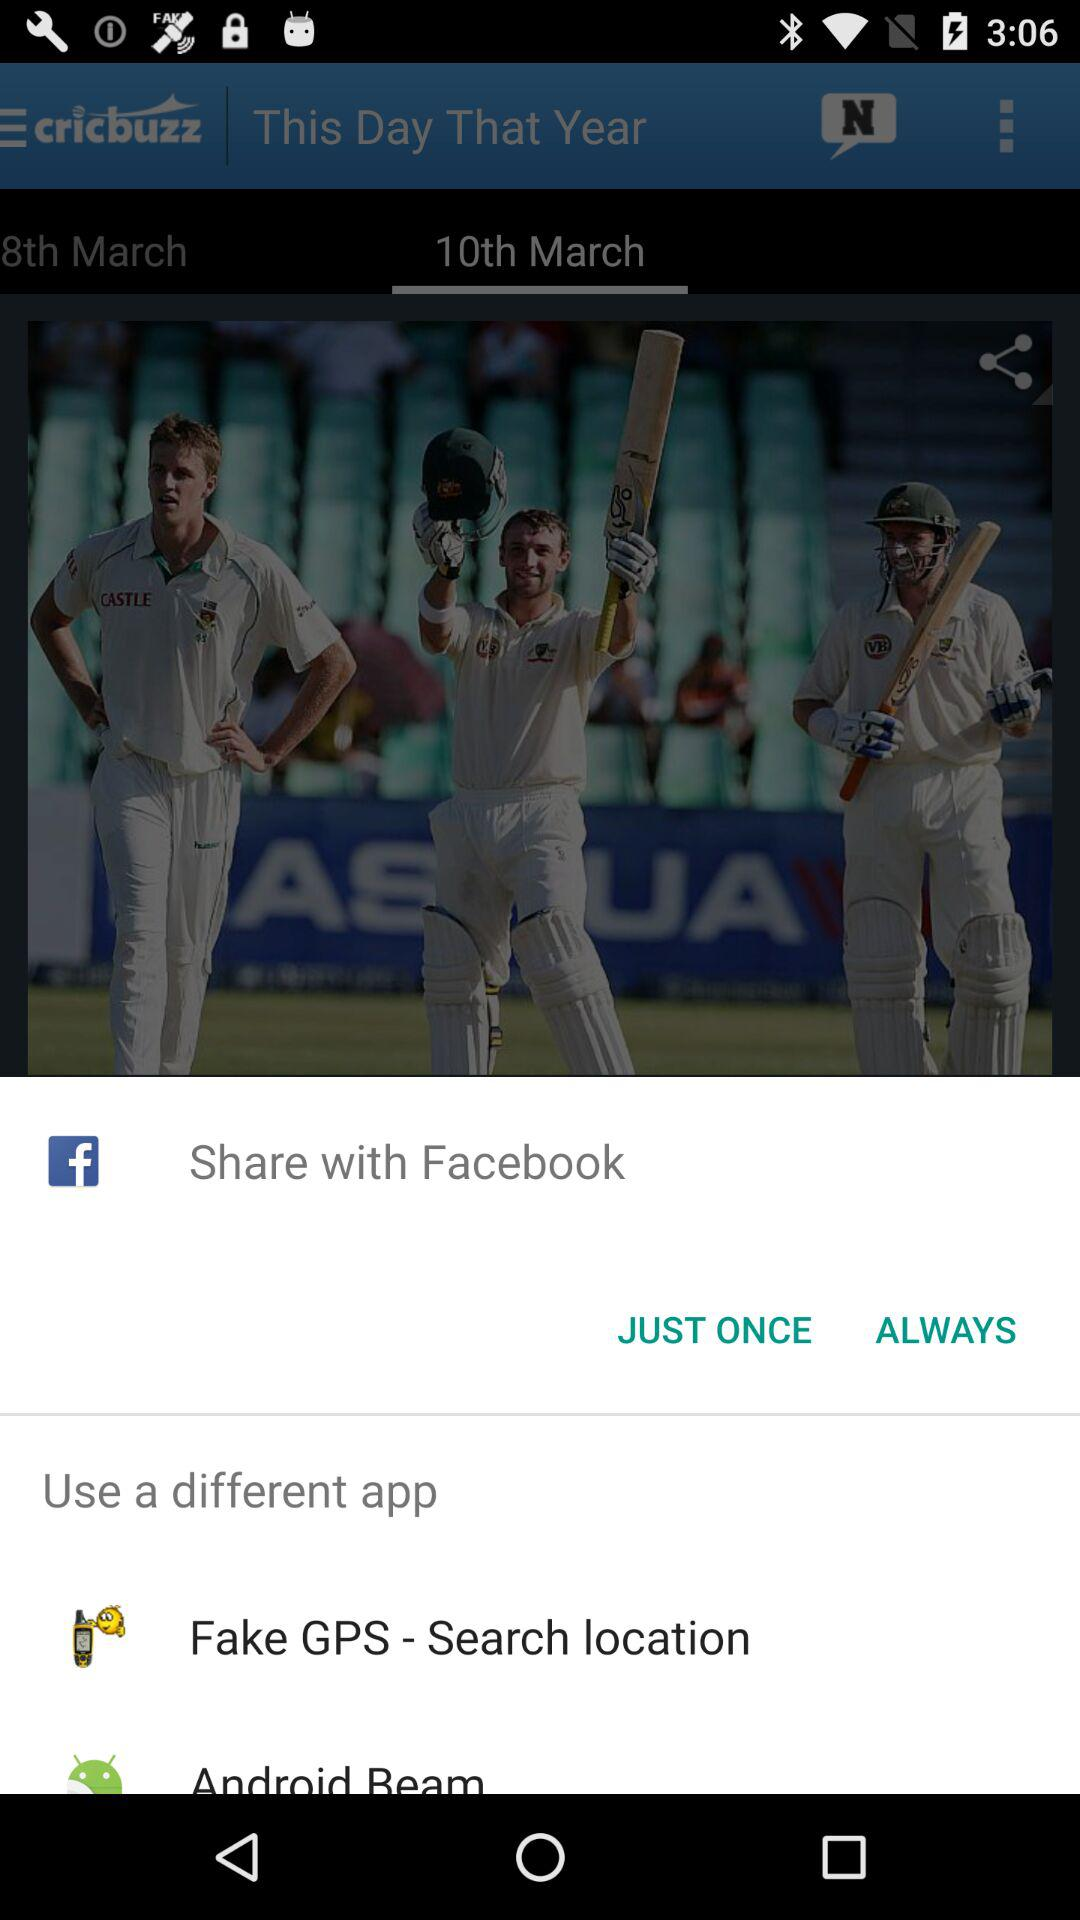What is the sharing option? The sharing options are "Facebook", "Fake GPS - Search location" and "Android Beam". 